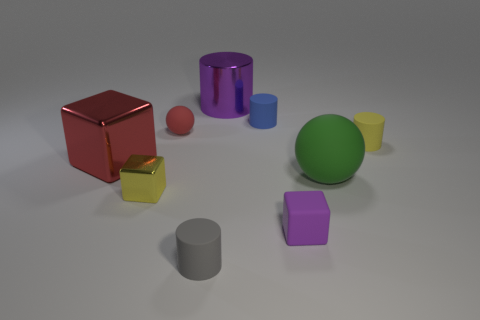Are there any red spheres that have the same material as the yellow cylinder?
Your response must be concise. Yes. There is a matte object that is on the left side of the gray object; does it have the same shape as the large rubber thing?
Your answer should be very brief. Yes. There is a yellow object that is to the left of the metallic thing that is behind the tiny red matte sphere; how many small rubber things are behind it?
Your answer should be compact. 3. Are there fewer tiny purple objects left of the small purple rubber object than spheres that are left of the red matte ball?
Your answer should be compact. No. There is another tiny thing that is the same shape as the green matte object; what is its color?
Your answer should be very brief. Red. The blue cylinder has what size?
Make the answer very short. Small. What number of other rubber blocks are the same size as the purple rubber block?
Your answer should be compact. 0. Is the big block the same color as the small matte ball?
Your answer should be very brief. Yes. Does the yellow object on the right side of the small yellow shiny cube have the same material as the tiny yellow object that is in front of the red metal object?
Offer a very short reply. No. Are there more large cylinders than cubes?
Offer a very short reply. No. 